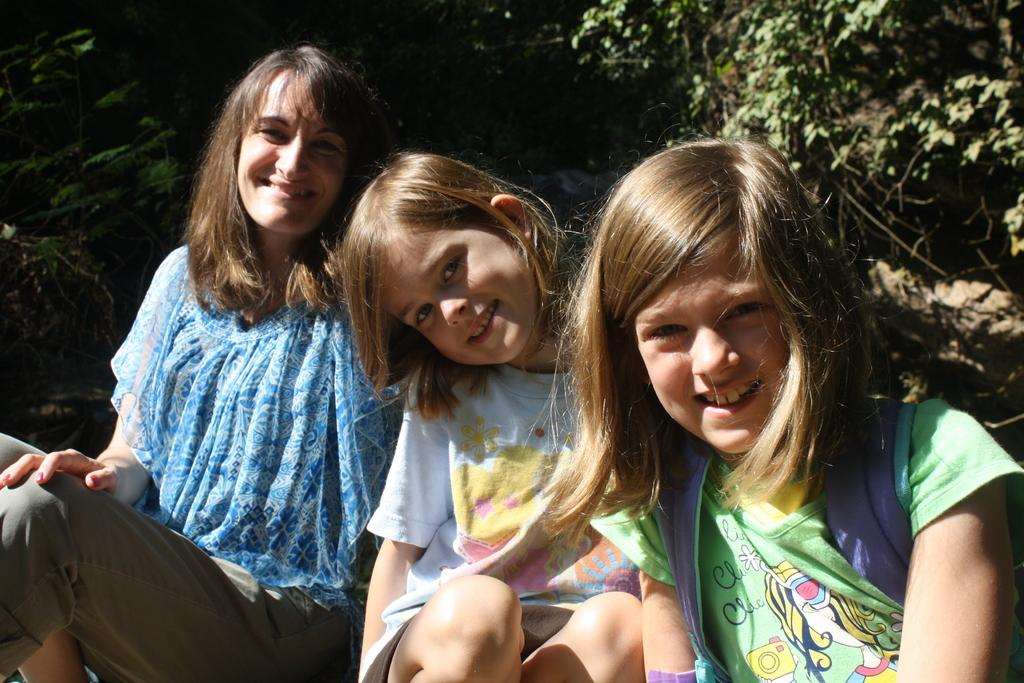How many people are in the image? There are three persons in the image. What is one person wearing? One person is wearing a white dress. What can be seen in the background of the image? There are trees in the background of the image. What is the color of the trees? The trees are green in color. What is the condition of the front door in the image? There is no front door visible in the image. How do the three persons say good-bye to each other in the image? The image does not show the three persons interacting or saying good-bye to each other. 